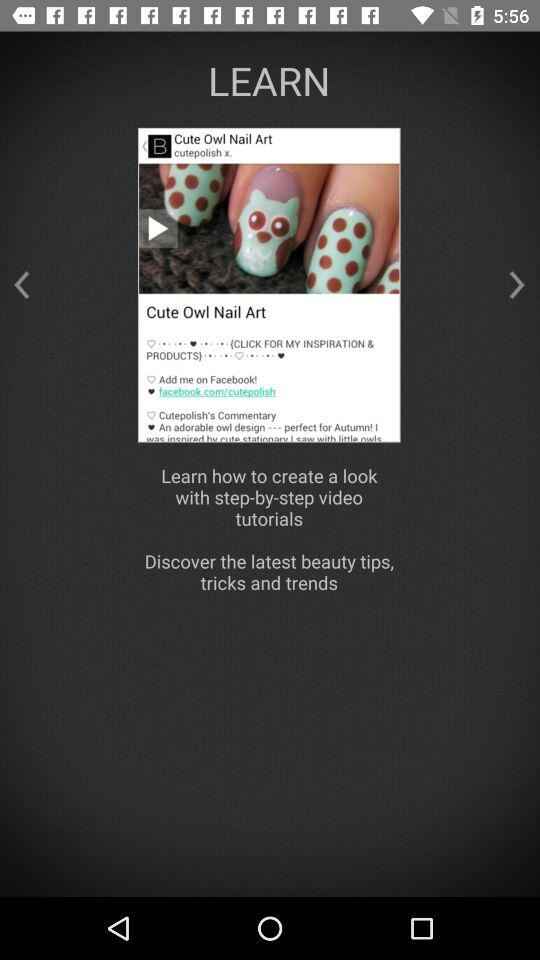What is the application name? The application name is "LEARN". 